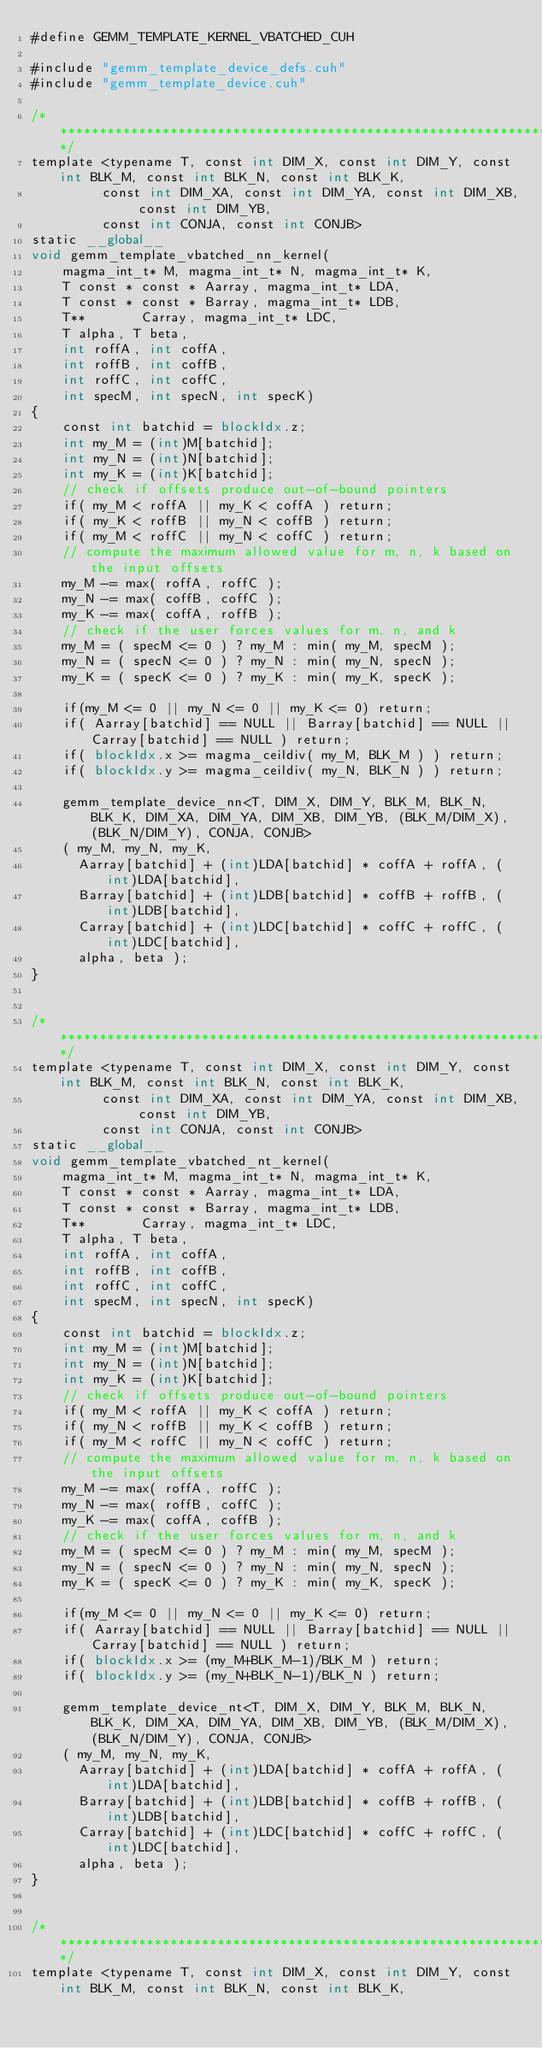<code> <loc_0><loc_0><loc_500><loc_500><_Cuda_>#define GEMM_TEMPLATE_KERNEL_VBATCHED_CUH

#include "gemm_template_device_defs.cuh"
#include "gemm_template_device.cuh"

/******************************************************************************/
template <typename T, const int DIM_X, const int DIM_Y, const int BLK_M, const int BLK_N, const int BLK_K, 
         const int DIM_XA, const int DIM_YA, const int DIM_XB, const int DIM_YB, 
         const int CONJA, const int CONJB>
static __global__
void gemm_template_vbatched_nn_kernel(
    magma_int_t* M, magma_int_t* N, magma_int_t* K,
    T const * const * Aarray, magma_int_t* LDA,
    T const * const * Barray, magma_int_t* LDB,
    T**       Carray, magma_int_t* LDC,
    T alpha, T beta, 
    int roffA, int coffA,
    int roffB, int coffB,
    int roffC, int coffC, 
    int specM, int specN, int specK)
{
    const int batchid = blockIdx.z;
    int my_M = (int)M[batchid];
    int my_N = (int)N[batchid];
    int my_K = (int)K[batchid];
    // check if offsets produce out-of-bound pointers
    if( my_M < roffA || my_K < coffA ) return;
    if( my_K < roffB || my_N < coffB ) return;
    if( my_M < roffC || my_N < coffC ) return;
    // compute the maximum allowed value for m, n, k based on the input offsets
    my_M -= max( roffA, roffC );
    my_N -= max( coffB, coffC );
    my_K -= max( coffA, roffB );
    // check if the user forces values for m, n, and k
    my_M = ( specM <= 0 ) ? my_M : min( my_M, specM );
    my_N = ( specN <= 0 ) ? my_N : min( my_N, specN );
    my_K = ( specK <= 0 ) ? my_K : min( my_K, specK );
    
    if(my_M <= 0 || my_N <= 0 || my_K <= 0) return;
    if( Aarray[batchid] == NULL || Barray[batchid] == NULL || Carray[batchid] == NULL ) return;
    if( blockIdx.x >= magma_ceildiv( my_M, BLK_M ) ) return;
    if( blockIdx.y >= magma_ceildiv( my_N, BLK_N ) ) return;
    
    gemm_template_device_nn<T, DIM_X, DIM_Y, BLK_M, BLK_N, BLK_K, DIM_XA, DIM_YA, DIM_XB, DIM_YB, (BLK_M/DIM_X), (BLK_N/DIM_Y), CONJA, CONJB>
    ( my_M, my_N, my_K, 
      Aarray[batchid] + (int)LDA[batchid] * coffA + roffA, (int)LDA[batchid], 
      Barray[batchid] + (int)LDB[batchid] * coffB + roffB, (int)LDB[batchid], 
      Carray[batchid] + (int)LDC[batchid] * coffC + roffC, (int)LDC[batchid], 
      alpha, beta );
}


/******************************************************************************/
template <typename T, const int DIM_X, const int DIM_Y, const int BLK_M, const int BLK_N, const int BLK_K, 
         const int DIM_XA, const int DIM_YA, const int DIM_XB, const int DIM_YB, 
         const int CONJA, const int CONJB>
static __global__
void gemm_template_vbatched_nt_kernel(
    magma_int_t* M, magma_int_t* N, magma_int_t* K,
    T const * const * Aarray, magma_int_t* LDA,
    T const * const * Barray, magma_int_t* LDB,
    T**       Carray, magma_int_t* LDC,
    T alpha, T beta, 
    int roffA, int coffA,
    int roffB, int coffB,
    int roffC, int coffC, 
    int specM, int specN, int specK)
{
    const int batchid = blockIdx.z;
    int my_M = (int)M[batchid];
    int my_N = (int)N[batchid];
    int my_K = (int)K[batchid];
    // check if offsets produce out-of-bound pointers
    if( my_M < roffA || my_K < coffA ) return;
    if( my_N < roffB || my_K < coffB ) return;
    if( my_M < roffC || my_N < coffC ) return;
    // compute the maximum allowed value for m, n, k based on the input offsets
    my_M -= max( roffA, roffC );
    my_N -= max( roffB, coffC );
    my_K -= max( coffA, coffB );
    // check if the user forces values for m, n, and k
    my_M = ( specM <= 0 ) ? my_M : min( my_M, specM );
    my_N = ( specN <= 0 ) ? my_N : min( my_N, specN );
    my_K = ( specK <= 0 ) ? my_K : min( my_K, specK );
    
    if(my_M <= 0 || my_N <= 0 || my_K <= 0) return;
    if( Aarray[batchid] == NULL || Barray[batchid] == NULL || Carray[batchid] == NULL ) return;
    if( blockIdx.x >= (my_M+BLK_M-1)/BLK_M ) return;
    if( blockIdx.y >= (my_N+BLK_N-1)/BLK_N ) return;
    
    gemm_template_device_nt<T, DIM_X, DIM_Y, BLK_M, BLK_N, BLK_K, DIM_XA, DIM_YA, DIM_XB, DIM_YB, (BLK_M/DIM_X), (BLK_N/DIM_Y), CONJA, CONJB>
    ( my_M, my_N, my_K, 
      Aarray[batchid] + (int)LDA[batchid] * coffA + roffA, (int)LDA[batchid], 
      Barray[batchid] + (int)LDB[batchid] * coffB + roffB, (int)LDB[batchid], 
      Carray[batchid] + (int)LDC[batchid] * coffC + roffC, (int)LDC[batchid], 
      alpha, beta );
}


/******************************************************************************/
template <typename T, const int DIM_X, const int DIM_Y, const int BLK_M, const int BLK_N, const int BLK_K, </code> 